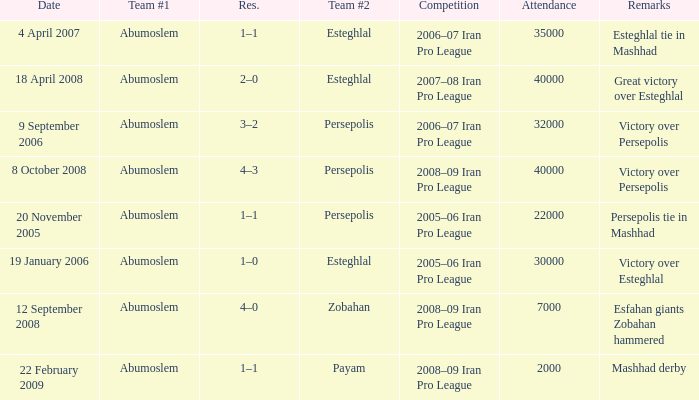Write the full table. {'header': ['Date', 'Team #1', 'Res.', 'Team #2', 'Competition', 'Attendance', 'Remarks'], 'rows': [['4 April 2007', 'Abumoslem', '1–1', 'Esteghlal', '2006–07 Iran Pro League', '35000', 'Esteghlal tie in Mashhad'], ['18 April 2008', 'Abumoslem', '2–0', 'Esteghlal', '2007–08 Iran Pro League', '40000', 'Great victory over Esteghlal'], ['9 September 2006', 'Abumoslem', '3–2', 'Persepolis', '2006–07 Iran Pro League', '32000', 'Victory over Persepolis'], ['8 October 2008', 'Abumoslem', '4–3', 'Persepolis', '2008–09 Iran Pro League', '40000', 'Victory over Persepolis'], ['20 November 2005', 'Abumoslem', '1–1', 'Persepolis', '2005–06 Iran Pro League', '22000', 'Persepolis tie in Mashhad'], ['19 January 2006', 'Abumoslem', '1–0', 'Esteghlal', '2005–06 Iran Pro League', '30000', 'Victory over Esteghlal'], ['12 September 2008', 'Abumoslem', '4–0', 'Zobahan', '2008–09 Iran Pro League', '7000', 'Esfahan giants Zobahan hammered'], ['22 February 2009', 'Abumoslem', '1–1', 'Payam', '2008–09 Iran Pro League', '2000', 'Mashhad derby']]} Who was team #1 on 9 September 2006? Abumoslem. 